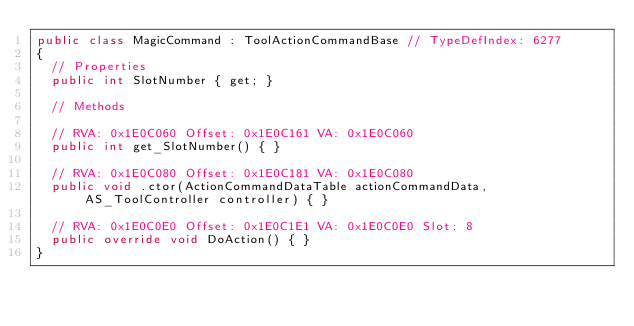Convert code to text. <code><loc_0><loc_0><loc_500><loc_500><_C#_>public class MagicCommand : ToolActionCommandBase // TypeDefIndex: 6277
{
	// Properties
	public int SlotNumber { get; }

	// Methods

	// RVA: 0x1E0C060 Offset: 0x1E0C161 VA: 0x1E0C060
	public int get_SlotNumber() { }

	// RVA: 0x1E0C080 Offset: 0x1E0C181 VA: 0x1E0C080
	public void .ctor(ActionCommandDataTable actionCommandData, AS_ToolController controller) { }

	// RVA: 0x1E0C0E0 Offset: 0x1E0C1E1 VA: 0x1E0C0E0 Slot: 8
	public override void DoAction() { }
}

</code> 